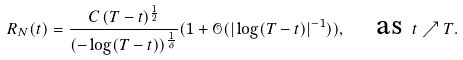Convert formula to latex. <formula><loc_0><loc_0><loc_500><loc_500>R _ { N } ( t ) = \frac { C \, ( T - t ) ^ { \frac { 1 } { 2 } } } { ( - \log ( T - t ) ) ^ { \frac { 1 } { \delta } } } ( 1 + \mathcal { O } ( | \log ( T - t ) | ^ { - 1 } ) ) , \quad \text {as } t \nearrow T .</formula> 